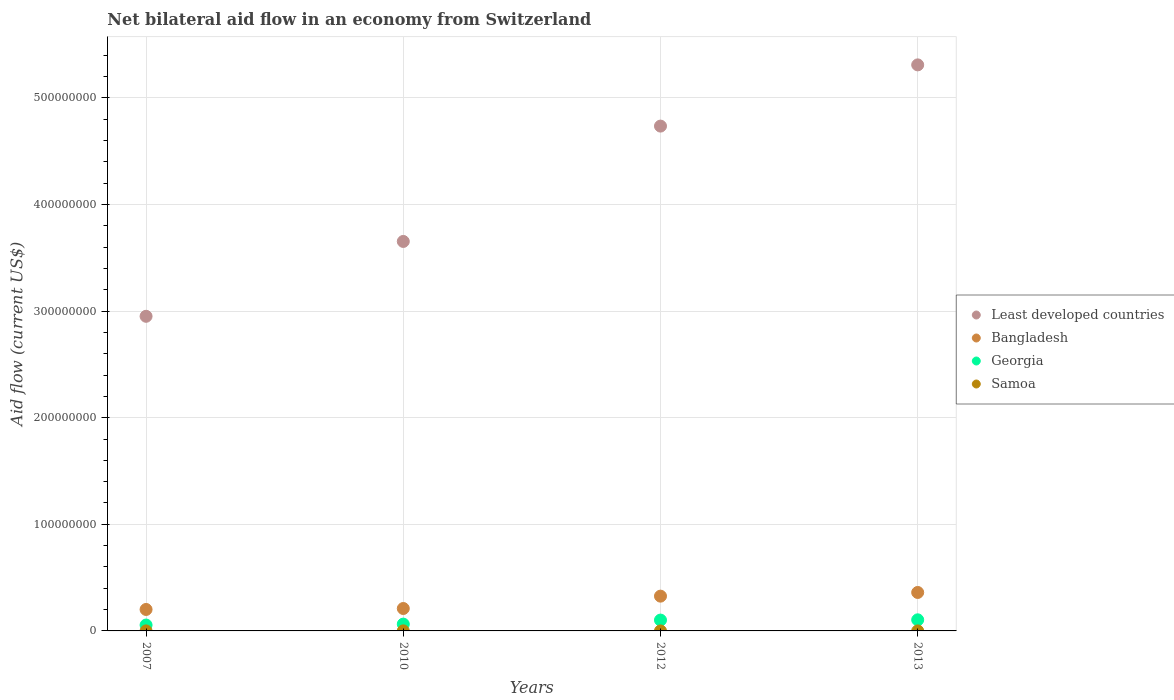Is the number of dotlines equal to the number of legend labels?
Your answer should be very brief. Yes. Across all years, what is the maximum net bilateral aid flow in Bangladesh?
Make the answer very short. 3.61e+07. Across all years, what is the minimum net bilateral aid flow in Least developed countries?
Give a very brief answer. 2.95e+08. In which year was the net bilateral aid flow in Georgia maximum?
Keep it short and to the point. 2013. What is the difference between the net bilateral aid flow in Samoa in 2007 and that in 2013?
Your answer should be very brief. 10000. What is the difference between the net bilateral aid flow in Samoa in 2007 and the net bilateral aid flow in Bangladesh in 2010?
Your answer should be very brief. -2.10e+07. What is the average net bilateral aid flow in Least developed countries per year?
Your answer should be compact. 4.16e+08. In the year 2010, what is the difference between the net bilateral aid flow in Georgia and net bilateral aid flow in Bangladesh?
Offer a terse response. -1.46e+07. What is the ratio of the net bilateral aid flow in Samoa in 2010 to that in 2012?
Ensure brevity in your answer.  5. Is the net bilateral aid flow in Bangladesh in 2010 less than that in 2013?
Ensure brevity in your answer.  Yes. What is the difference between the highest and the lowest net bilateral aid flow in Least developed countries?
Give a very brief answer. 2.36e+08. Is it the case that in every year, the sum of the net bilateral aid flow in Georgia and net bilateral aid flow in Bangladesh  is greater than the sum of net bilateral aid flow in Samoa and net bilateral aid flow in Least developed countries?
Offer a terse response. No. Does the net bilateral aid flow in Bangladesh monotonically increase over the years?
Ensure brevity in your answer.  Yes. Is the net bilateral aid flow in Bangladesh strictly greater than the net bilateral aid flow in Samoa over the years?
Your answer should be very brief. Yes. How many dotlines are there?
Your answer should be very brief. 4. Does the graph contain any zero values?
Ensure brevity in your answer.  No. Does the graph contain grids?
Your answer should be compact. Yes. How are the legend labels stacked?
Provide a succinct answer. Vertical. What is the title of the graph?
Make the answer very short. Net bilateral aid flow in an economy from Switzerland. Does "Arab World" appear as one of the legend labels in the graph?
Your response must be concise. No. What is the label or title of the Y-axis?
Your response must be concise. Aid flow (current US$). What is the Aid flow (current US$) of Least developed countries in 2007?
Ensure brevity in your answer.  2.95e+08. What is the Aid flow (current US$) of Bangladesh in 2007?
Your answer should be compact. 2.01e+07. What is the Aid flow (current US$) of Georgia in 2007?
Provide a short and direct response. 5.52e+06. What is the Aid flow (current US$) of Least developed countries in 2010?
Your answer should be very brief. 3.65e+08. What is the Aid flow (current US$) of Bangladesh in 2010?
Give a very brief answer. 2.10e+07. What is the Aid flow (current US$) of Georgia in 2010?
Provide a short and direct response. 6.39e+06. What is the Aid flow (current US$) in Samoa in 2010?
Offer a terse response. 5.00e+04. What is the Aid flow (current US$) of Least developed countries in 2012?
Your response must be concise. 4.74e+08. What is the Aid flow (current US$) of Bangladesh in 2012?
Ensure brevity in your answer.  3.26e+07. What is the Aid flow (current US$) of Georgia in 2012?
Make the answer very short. 1.02e+07. What is the Aid flow (current US$) in Least developed countries in 2013?
Keep it short and to the point. 5.31e+08. What is the Aid flow (current US$) of Bangladesh in 2013?
Offer a terse response. 3.61e+07. What is the Aid flow (current US$) in Georgia in 2013?
Ensure brevity in your answer.  1.04e+07. What is the Aid flow (current US$) of Samoa in 2013?
Offer a very short reply. 10000. Across all years, what is the maximum Aid flow (current US$) in Least developed countries?
Your answer should be very brief. 5.31e+08. Across all years, what is the maximum Aid flow (current US$) in Bangladesh?
Give a very brief answer. 3.61e+07. Across all years, what is the maximum Aid flow (current US$) of Georgia?
Offer a very short reply. 1.04e+07. Across all years, what is the maximum Aid flow (current US$) in Samoa?
Keep it short and to the point. 5.00e+04. Across all years, what is the minimum Aid flow (current US$) in Least developed countries?
Your answer should be compact. 2.95e+08. Across all years, what is the minimum Aid flow (current US$) of Bangladesh?
Provide a short and direct response. 2.01e+07. Across all years, what is the minimum Aid flow (current US$) in Georgia?
Offer a very short reply. 5.52e+06. Across all years, what is the minimum Aid flow (current US$) of Samoa?
Provide a short and direct response. 10000. What is the total Aid flow (current US$) in Least developed countries in the graph?
Give a very brief answer. 1.67e+09. What is the total Aid flow (current US$) of Bangladesh in the graph?
Provide a succinct answer. 1.10e+08. What is the total Aid flow (current US$) in Georgia in the graph?
Your answer should be compact. 3.25e+07. What is the total Aid flow (current US$) in Samoa in the graph?
Your answer should be compact. 9.00e+04. What is the difference between the Aid flow (current US$) of Least developed countries in 2007 and that in 2010?
Keep it short and to the point. -7.02e+07. What is the difference between the Aid flow (current US$) of Bangladesh in 2007 and that in 2010?
Offer a terse response. -9.00e+05. What is the difference between the Aid flow (current US$) of Georgia in 2007 and that in 2010?
Provide a succinct answer. -8.70e+05. What is the difference between the Aid flow (current US$) of Least developed countries in 2007 and that in 2012?
Your answer should be very brief. -1.78e+08. What is the difference between the Aid flow (current US$) in Bangladesh in 2007 and that in 2012?
Keep it short and to the point. -1.25e+07. What is the difference between the Aid flow (current US$) of Georgia in 2007 and that in 2012?
Provide a succinct answer. -4.65e+06. What is the difference between the Aid flow (current US$) in Least developed countries in 2007 and that in 2013?
Offer a terse response. -2.36e+08. What is the difference between the Aid flow (current US$) in Bangladesh in 2007 and that in 2013?
Your response must be concise. -1.60e+07. What is the difference between the Aid flow (current US$) of Georgia in 2007 and that in 2013?
Your answer should be very brief. -4.89e+06. What is the difference between the Aid flow (current US$) in Samoa in 2007 and that in 2013?
Offer a terse response. 10000. What is the difference between the Aid flow (current US$) of Least developed countries in 2010 and that in 2012?
Ensure brevity in your answer.  -1.08e+08. What is the difference between the Aid flow (current US$) of Bangladesh in 2010 and that in 2012?
Your answer should be very brief. -1.16e+07. What is the difference between the Aid flow (current US$) of Georgia in 2010 and that in 2012?
Your answer should be compact. -3.78e+06. What is the difference between the Aid flow (current US$) of Samoa in 2010 and that in 2012?
Offer a very short reply. 4.00e+04. What is the difference between the Aid flow (current US$) of Least developed countries in 2010 and that in 2013?
Ensure brevity in your answer.  -1.66e+08. What is the difference between the Aid flow (current US$) in Bangladesh in 2010 and that in 2013?
Provide a succinct answer. -1.50e+07. What is the difference between the Aid flow (current US$) of Georgia in 2010 and that in 2013?
Your response must be concise. -4.02e+06. What is the difference between the Aid flow (current US$) in Least developed countries in 2012 and that in 2013?
Your answer should be compact. -5.74e+07. What is the difference between the Aid flow (current US$) of Bangladesh in 2012 and that in 2013?
Keep it short and to the point. -3.46e+06. What is the difference between the Aid flow (current US$) of Least developed countries in 2007 and the Aid flow (current US$) of Bangladesh in 2010?
Provide a succinct answer. 2.74e+08. What is the difference between the Aid flow (current US$) in Least developed countries in 2007 and the Aid flow (current US$) in Georgia in 2010?
Keep it short and to the point. 2.89e+08. What is the difference between the Aid flow (current US$) of Least developed countries in 2007 and the Aid flow (current US$) of Samoa in 2010?
Offer a very short reply. 2.95e+08. What is the difference between the Aid flow (current US$) in Bangladesh in 2007 and the Aid flow (current US$) in Georgia in 2010?
Make the answer very short. 1.37e+07. What is the difference between the Aid flow (current US$) in Bangladesh in 2007 and the Aid flow (current US$) in Samoa in 2010?
Your answer should be compact. 2.01e+07. What is the difference between the Aid flow (current US$) in Georgia in 2007 and the Aid flow (current US$) in Samoa in 2010?
Your answer should be compact. 5.47e+06. What is the difference between the Aid flow (current US$) in Least developed countries in 2007 and the Aid flow (current US$) in Bangladesh in 2012?
Ensure brevity in your answer.  2.63e+08. What is the difference between the Aid flow (current US$) of Least developed countries in 2007 and the Aid flow (current US$) of Georgia in 2012?
Your answer should be compact. 2.85e+08. What is the difference between the Aid flow (current US$) in Least developed countries in 2007 and the Aid flow (current US$) in Samoa in 2012?
Offer a very short reply. 2.95e+08. What is the difference between the Aid flow (current US$) of Bangladesh in 2007 and the Aid flow (current US$) of Georgia in 2012?
Ensure brevity in your answer.  9.96e+06. What is the difference between the Aid flow (current US$) in Bangladesh in 2007 and the Aid flow (current US$) in Samoa in 2012?
Give a very brief answer. 2.01e+07. What is the difference between the Aid flow (current US$) of Georgia in 2007 and the Aid flow (current US$) of Samoa in 2012?
Offer a very short reply. 5.51e+06. What is the difference between the Aid flow (current US$) of Least developed countries in 2007 and the Aid flow (current US$) of Bangladesh in 2013?
Your answer should be compact. 2.59e+08. What is the difference between the Aid flow (current US$) of Least developed countries in 2007 and the Aid flow (current US$) of Georgia in 2013?
Give a very brief answer. 2.85e+08. What is the difference between the Aid flow (current US$) of Least developed countries in 2007 and the Aid flow (current US$) of Samoa in 2013?
Offer a very short reply. 2.95e+08. What is the difference between the Aid flow (current US$) of Bangladesh in 2007 and the Aid flow (current US$) of Georgia in 2013?
Your answer should be very brief. 9.72e+06. What is the difference between the Aid flow (current US$) in Bangladesh in 2007 and the Aid flow (current US$) in Samoa in 2013?
Keep it short and to the point. 2.01e+07. What is the difference between the Aid flow (current US$) in Georgia in 2007 and the Aid flow (current US$) in Samoa in 2013?
Your answer should be compact. 5.51e+06. What is the difference between the Aid flow (current US$) of Least developed countries in 2010 and the Aid flow (current US$) of Bangladesh in 2012?
Provide a short and direct response. 3.33e+08. What is the difference between the Aid flow (current US$) of Least developed countries in 2010 and the Aid flow (current US$) of Georgia in 2012?
Give a very brief answer. 3.55e+08. What is the difference between the Aid flow (current US$) in Least developed countries in 2010 and the Aid flow (current US$) in Samoa in 2012?
Your answer should be very brief. 3.65e+08. What is the difference between the Aid flow (current US$) in Bangladesh in 2010 and the Aid flow (current US$) in Georgia in 2012?
Provide a succinct answer. 1.09e+07. What is the difference between the Aid flow (current US$) in Bangladesh in 2010 and the Aid flow (current US$) in Samoa in 2012?
Your response must be concise. 2.10e+07. What is the difference between the Aid flow (current US$) in Georgia in 2010 and the Aid flow (current US$) in Samoa in 2012?
Ensure brevity in your answer.  6.38e+06. What is the difference between the Aid flow (current US$) of Least developed countries in 2010 and the Aid flow (current US$) of Bangladesh in 2013?
Give a very brief answer. 3.29e+08. What is the difference between the Aid flow (current US$) in Least developed countries in 2010 and the Aid flow (current US$) in Georgia in 2013?
Give a very brief answer. 3.55e+08. What is the difference between the Aid flow (current US$) of Least developed countries in 2010 and the Aid flow (current US$) of Samoa in 2013?
Keep it short and to the point. 3.65e+08. What is the difference between the Aid flow (current US$) of Bangladesh in 2010 and the Aid flow (current US$) of Georgia in 2013?
Your response must be concise. 1.06e+07. What is the difference between the Aid flow (current US$) of Bangladesh in 2010 and the Aid flow (current US$) of Samoa in 2013?
Keep it short and to the point. 2.10e+07. What is the difference between the Aid flow (current US$) in Georgia in 2010 and the Aid flow (current US$) in Samoa in 2013?
Offer a terse response. 6.38e+06. What is the difference between the Aid flow (current US$) of Least developed countries in 2012 and the Aid flow (current US$) of Bangladesh in 2013?
Provide a short and direct response. 4.37e+08. What is the difference between the Aid flow (current US$) in Least developed countries in 2012 and the Aid flow (current US$) in Georgia in 2013?
Ensure brevity in your answer.  4.63e+08. What is the difference between the Aid flow (current US$) of Least developed countries in 2012 and the Aid flow (current US$) of Samoa in 2013?
Your response must be concise. 4.74e+08. What is the difference between the Aid flow (current US$) in Bangladesh in 2012 and the Aid flow (current US$) in Georgia in 2013?
Ensure brevity in your answer.  2.22e+07. What is the difference between the Aid flow (current US$) in Bangladesh in 2012 and the Aid flow (current US$) in Samoa in 2013?
Keep it short and to the point. 3.26e+07. What is the difference between the Aid flow (current US$) of Georgia in 2012 and the Aid flow (current US$) of Samoa in 2013?
Offer a terse response. 1.02e+07. What is the average Aid flow (current US$) of Least developed countries per year?
Provide a succinct answer. 4.16e+08. What is the average Aid flow (current US$) of Bangladesh per year?
Keep it short and to the point. 2.75e+07. What is the average Aid flow (current US$) of Georgia per year?
Offer a very short reply. 8.12e+06. What is the average Aid flow (current US$) in Samoa per year?
Keep it short and to the point. 2.25e+04. In the year 2007, what is the difference between the Aid flow (current US$) in Least developed countries and Aid flow (current US$) in Bangladesh?
Your answer should be very brief. 2.75e+08. In the year 2007, what is the difference between the Aid flow (current US$) in Least developed countries and Aid flow (current US$) in Georgia?
Your answer should be compact. 2.90e+08. In the year 2007, what is the difference between the Aid flow (current US$) in Least developed countries and Aid flow (current US$) in Samoa?
Your response must be concise. 2.95e+08. In the year 2007, what is the difference between the Aid flow (current US$) in Bangladesh and Aid flow (current US$) in Georgia?
Your response must be concise. 1.46e+07. In the year 2007, what is the difference between the Aid flow (current US$) of Bangladesh and Aid flow (current US$) of Samoa?
Keep it short and to the point. 2.01e+07. In the year 2007, what is the difference between the Aid flow (current US$) in Georgia and Aid flow (current US$) in Samoa?
Keep it short and to the point. 5.50e+06. In the year 2010, what is the difference between the Aid flow (current US$) in Least developed countries and Aid flow (current US$) in Bangladesh?
Your answer should be very brief. 3.44e+08. In the year 2010, what is the difference between the Aid flow (current US$) in Least developed countries and Aid flow (current US$) in Georgia?
Offer a very short reply. 3.59e+08. In the year 2010, what is the difference between the Aid flow (current US$) of Least developed countries and Aid flow (current US$) of Samoa?
Give a very brief answer. 3.65e+08. In the year 2010, what is the difference between the Aid flow (current US$) in Bangladesh and Aid flow (current US$) in Georgia?
Ensure brevity in your answer.  1.46e+07. In the year 2010, what is the difference between the Aid flow (current US$) in Bangladesh and Aid flow (current US$) in Samoa?
Give a very brief answer. 2.10e+07. In the year 2010, what is the difference between the Aid flow (current US$) in Georgia and Aid flow (current US$) in Samoa?
Provide a short and direct response. 6.34e+06. In the year 2012, what is the difference between the Aid flow (current US$) in Least developed countries and Aid flow (current US$) in Bangladesh?
Ensure brevity in your answer.  4.41e+08. In the year 2012, what is the difference between the Aid flow (current US$) of Least developed countries and Aid flow (current US$) of Georgia?
Provide a short and direct response. 4.63e+08. In the year 2012, what is the difference between the Aid flow (current US$) of Least developed countries and Aid flow (current US$) of Samoa?
Keep it short and to the point. 4.74e+08. In the year 2012, what is the difference between the Aid flow (current US$) of Bangladesh and Aid flow (current US$) of Georgia?
Your answer should be very brief. 2.24e+07. In the year 2012, what is the difference between the Aid flow (current US$) in Bangladesh and Aid flow (current US$) in Samoa?
Ensure brevity in your answer.  3.26e+07. In the year 2012, what is the difference between the Aid flow (current US$) of Georgia and Aid flow (current US$) of Samoa?
Provide a short and direct response. 1.02e+07. In the year 2013, what is the difference between the Aid flow (current US$) of Least developed countries and Aid flow (current US$) of Bangladesh?
Ensure brevity in your answer.  4.95e+08. In the year 2013, what is the difference between the Aid flow (current US$) of Least developed countries and Aid flow (current US$) of Georgia?
Your answer should be very brief. 5.21e+08. In the year 2013, what is the difference between the Aid flow (current US$) of Least developed countries and Aid flow (current US$) of Samoa?
Give a very brief answer. 5.31e+08. In the year 2013, what is the difference between the Aid flow (current US$) of Bangladesh and Aid flow (current US$) of Georgia?
Provide a succinct answer. 2.57e+07. In the year 2013, what is the difference between the Aid flow (current US$) of Bangladesh and Aid flow (current US$) of Samoa?
Your answer should be compact. 3.61e+07. In the year 2013, what is the difference between the Aid flow (current US$) of Georgia and Aid flow (current US$) of Samoa?
Ensure brevity in your answer.  1.04e+07. What is the ratio of the Aid flow (current US$) of Least developed countries in 2007 to that in 2010?
Offer a terse response. 0.81. What is the ratio of the Aid flow (current US$) of Bangladesh in 2007 to that in 2010?
Give a very brief answer. 0.96. What is the ratio of the Aid flow (current US$) of Georgia in 2007 to that in 2010?
Ensure brevity in your answer.  0.86. What is the ratio of the Aid flow (current US$) of Samoa in 2007 to that in 2010?
Your answer should be compact. 0.4. What is the ratio of the Aid flow (current US$) of Least developed countries in 2007 to that in 2012?
Offer a very short reply. 0.62. What is the ratio of the Aid flow (current US$) in Bangladesh in 2007 to that in 2012?
Offer a terse response. 0.62. What is the ratio of the Aid flow (current US$) of Georgia in 2007 to that in 2012?
Offer a very short reply. 0.54. What is the ratio of the Aid flow (current US$) in Least developed countries in 2007 to that in 2013?
Offer a terse response. 0.56. What is the ratio of the Aid flow (current US$) in Bangladesh in 2007 to that in 2013?
Your answer should be compact. 0.56. What is the ratio of the Aid flow (current US$) of Georgia in 2007 to that in 2013?
Offer a very short reply. 0.53. What is the ratio of the Aid flow (current US$) of Least developed countries in 2010 to that in 2012?
Provide a short and direct response. 0.77. What is the ratio of the Aid flow (current US$) in Bangladesh in 2010 to that in 2012?
Provide a succinct answer. 0.64. What is the ratio of the Aid flow (current US$) of Georgia in 2010 to that in 2012?
Provide a succinct answer. 0.63. What is the ratio of the Aid flow (current US$) in Samoa in 2010 to that in 2012?
Offer a terse response. 5. What is the ratio of the Aid flow (current US$) in Least developed countries in 2010 to that in 2013?
Ensure brevity in your answer.  0.69. What is the ratio of the Aid flow (current US$) in Bangladesh in 2010 to that in 2013?
Your response must be concise. 0.58. What is the ratio of the Aid flow (current US$) of Georgia in 2010 to that in 2013?
Keep it short and to the point. 0.61. What is the ratio of the Aid flow (current US$) of Samoa in 2010 to that in 2013?
Provide a succinct answer. 5. What is the ratio of the Aid flow (current US$) of Least developed countries in 2012 to that in 2013?
Your answer should be very brief. 0.89. What is the ratio of the Aid flow (current US$) in Bangladesh in 2012 to that in 2013?
Make the answer very short. 0.9. What is the ratio of the Aid flow (current US$) in Georgia in 2012 to that in 2013?
Ensure brevity in your answer.  0.98. What is the difference between the highest and the second highest Aid flow (current US$) of Least developed countries?
Your response must be concise. 5.74e+07. What is the difference between the highest and the second highest Aid flow (current US$) of Bangladesh?
Keep it short and to the point. 3.46e+06. What is the difference between the highest and the second highest Aid flow (current US$) of Georgia?
Keep it short and to the point. 2.40e+05. What is the difference between the highest and the lowest Aid flow (current US$) of Least developed countries?
Your answer should be very brief. 2.36e+08. What is the difference between the highest and the lowest Aid flow (current US$) of Bangladesh?
Your response must be concise. 1.60e+07. What is the difference between the highest and the lowest Aid flow (current US$) of Georgia?
Offer a very short reply. 4.89e+06. 